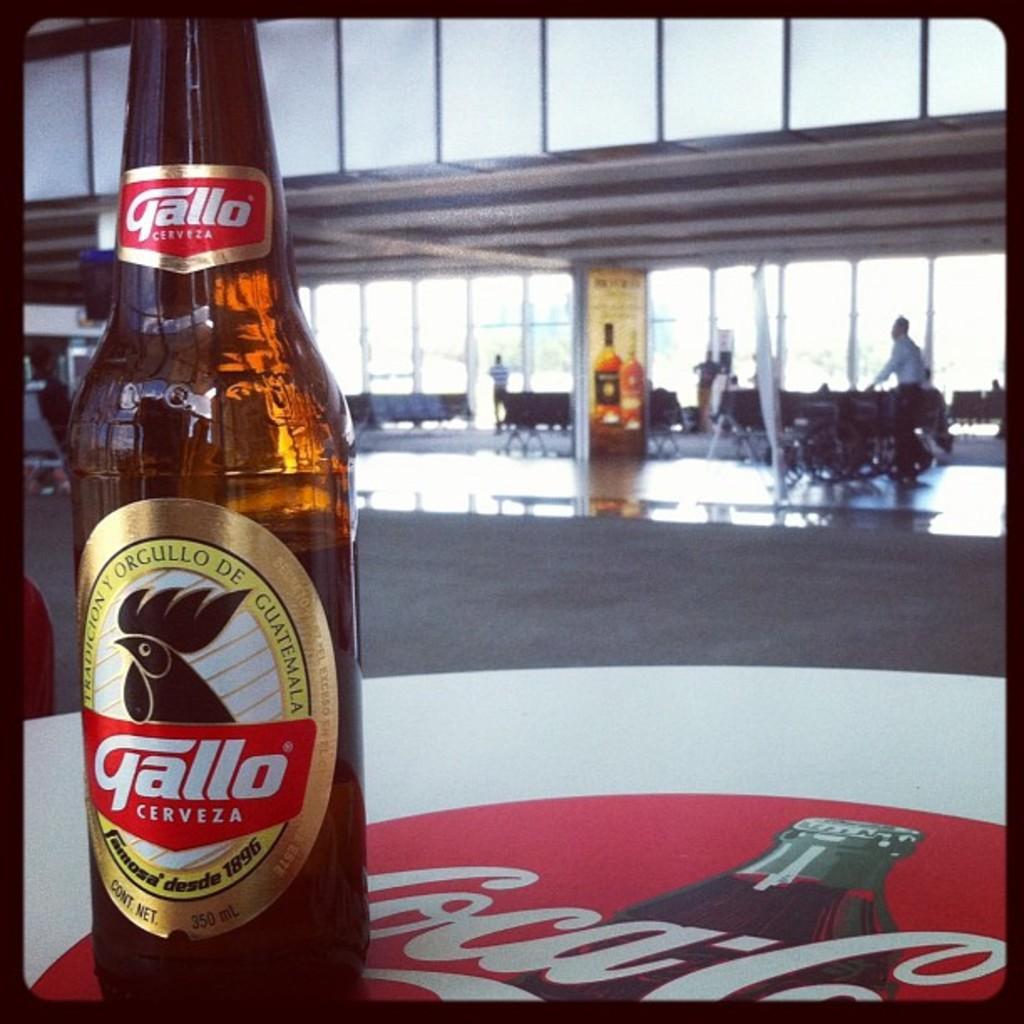In one or two sentences, can you explain what this image depicts? This is the picture taken in a room, there is a glass bottle on the floor and the floor is covered with painting and the painting is in white and red color. Behind the bottle there are chairs and persons on the floor and a glass door and a pillars. 